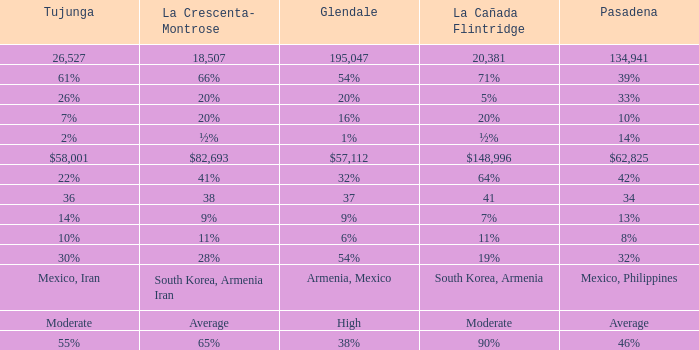What is the ratio of tukunga when la crescenta-montrose makes up 28%? 30%. 